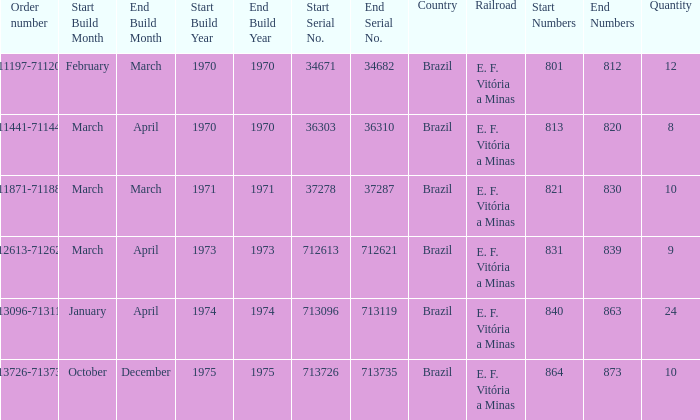What is the count of railroads with the numbers 864-873? 1.0. 